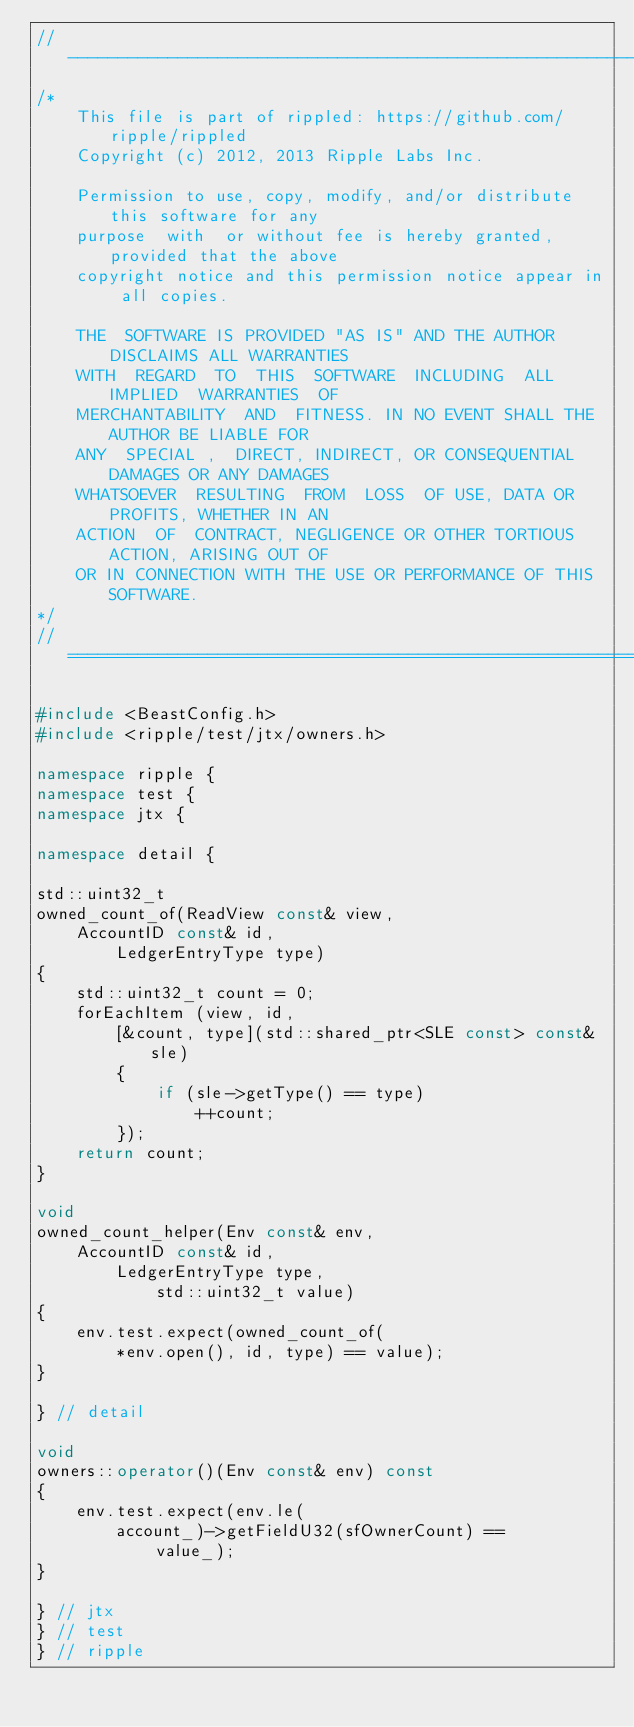<code> <loc_0><loc_0><loc_500><loc_500><_C++_>//------------------------------------------------------------------------------
/*
    This file is part of rippled: https://github.com/ripple/rippled
    Copyright (c) 2012, 2013 Ripple Labs Inc.

    Permission to use, copy, modify, and/or distribute this software for any
    purpose  with  or without fee is hereby granted, provided that the above
    copyright notice and this permission notice appear in all copies.

    THE  SOFTWARE IS PROVIDED "AS IS" AND THE AUTHOR DISCLAIMS ALL WARRANTIES
    WITH  REGARD  TO  THIS  SOFTWARE  INCLUDING  ALL  IMPLIED  WARRANTIES  OF
    MERCHANTABILITY  AND  FITNESS. IN NO EVENT SHALL THE AUTHOR BE LIABLE FOR
    ANY  SPECIAL ,  DIRECT, INDIRECT, OR CONSEQUENTIAL DAMAGES OR ANY DAMAGES
    WHATSOEVER  RESULTING  FROM  LOSS  OF USE, DATA OR PROFITS, WHETHER IN AN
    ACTION  OF  CONTRACT, NEGLIGENCE OR OTHER TORTIOUS ACTION, ARISING OUT OF
    OR IN CONNECTION WITH THE USE OR PERFORMANCE OF THIS SOFTWARE.
*/
//==============================================================================

#include <BeastConfig.h>
#include <ripple/test/jtx/owners.h>

namespace ripple {
namespace test {
namespace jtx {

namespace detail {

std::uint32_t
owned_count_of(ReadView const& view,
    AccountID const& id,
        LedgerEntryType type)
{
    std::uint32_t count = 0;
    forEachItem (view, id,
        [&count, type](std::shared_ptr<SLE const> const& sle)
        {
            if (sle->getType() == type)
                ++count;
        });
    return count;
}

void
owned_count_helper(Env const& env,
    AccountID const& id,
        LedgerEntryType type,
            std::uint32_t value)
{
    env.test.expect(owned_count_of(
        *env.open(), id, type) == value);
}

} // detail

void
owners::operator()(Env const& env) const
{
    env.test.expect(env.le(
        account_)->getFieldU32(sfOwnerCount) ==
            value_);
}

} // jtx
} // test
} // ripple
</code> 